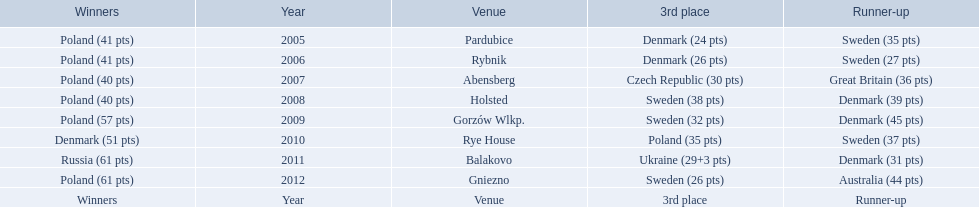Did holland win the 2010 championship? if not who did? Rye House. What did position did holland they rank? 3rd place. 